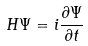<formula> <loc_0><loc_0><loc_500><loc_500>H \Psi = i \frac { \partial \Psi } { \partial t }</formula> 